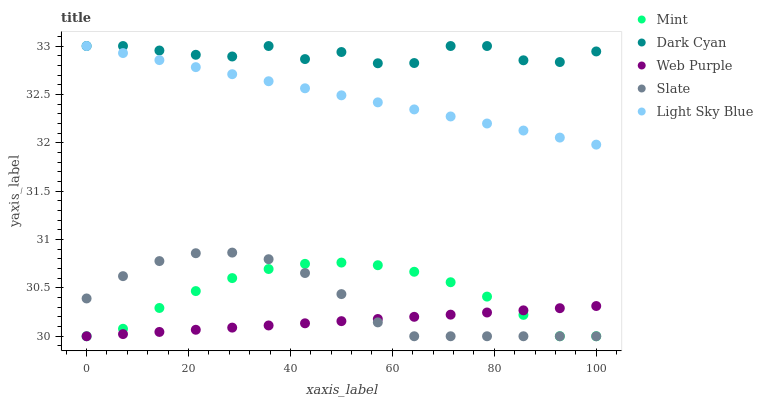Does Web Purple have the minimum area under the curve?
Answer yes or no. Yes. Does Dark Cyan have the maximum area under the curve?
Answer yes or no. Yes. Does Light Sky Blue have the minimum area under the curve?
Answer yes or no. No. Does Light Sky Blue have the maximum area under the curve?
Answer yes or no. No. Is Light Sky Blue the smoothest?
Answer yes or no. Yes. Is Dark Cyan the roughest?
Answer yes or no. Yes. Is Web Purple the smoothest?
Answer yes or no. No. Is Web Purple the roughest?
Answer yes or no. No. Does Web Purple have the lowest value?
Answer yes or no. Yes. Does Light Sky Blue have the lowest value?
Answer yes or no. No. Does Light Sky Blue have the highest value?
Answer yes or no. Yes. Does Web Purple have the highest value?
Answer yes or no. No. Is Mint less than Light Sky Blue?
Answer yes or no. Yes. Is Light Sky Blue greater than Web Purple?
Answer yes or no. Yes. Does Light Sky Blue intersect Dark Cyan?
Answer yes or no. Yes. Is Light Sky Blue less than Dark Cyan?
Answer yes or no. No. Is Light Sky Blue greater than Dark Cyan?
Answer yes or no. No. Does Mint intersect Light Sky Blue?
Answer yes or no. No. 